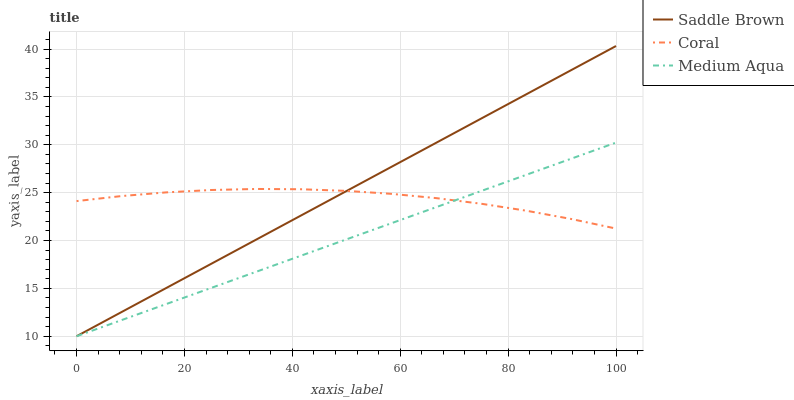Does Medium Aqua have the minimum area under the curve?
Answer yes or no. Yes. Does Saddle Brown have the maximum area under the curve?
Answer yes or no. Yes. Does Saddle Brown have the minimum area under the curve?
Answer yes or no. No. Does Medium Aqua have the maximum area under the curve?
Answer yes or no. No. Is Saddle Brown the smoothest?
Answer yes or no. Yes. Is Coral the roughest?
Answer yes or no. Yes. Is Medium Aqua the smoothest?
Answer yes or no. No. Is Medium Aqua the roughest?
Answer yes or no. No. Does Medium Aqua have the lowest value?
Answer yes or no. Yes. Does Saddle Brown have the highest value?
Answer yes or no. Yes. Does Medium Aqua have the highest value?
Answer yes or no. No. Does Saddle Brown intersect Medium Aqua?
Answer yes or no. Yes. Is Saddle Brown less than Medium Aqua?
Answer yes or no. No. Is Saddle Brown greater than Medium Aqua?
Answer yes or no. No. 